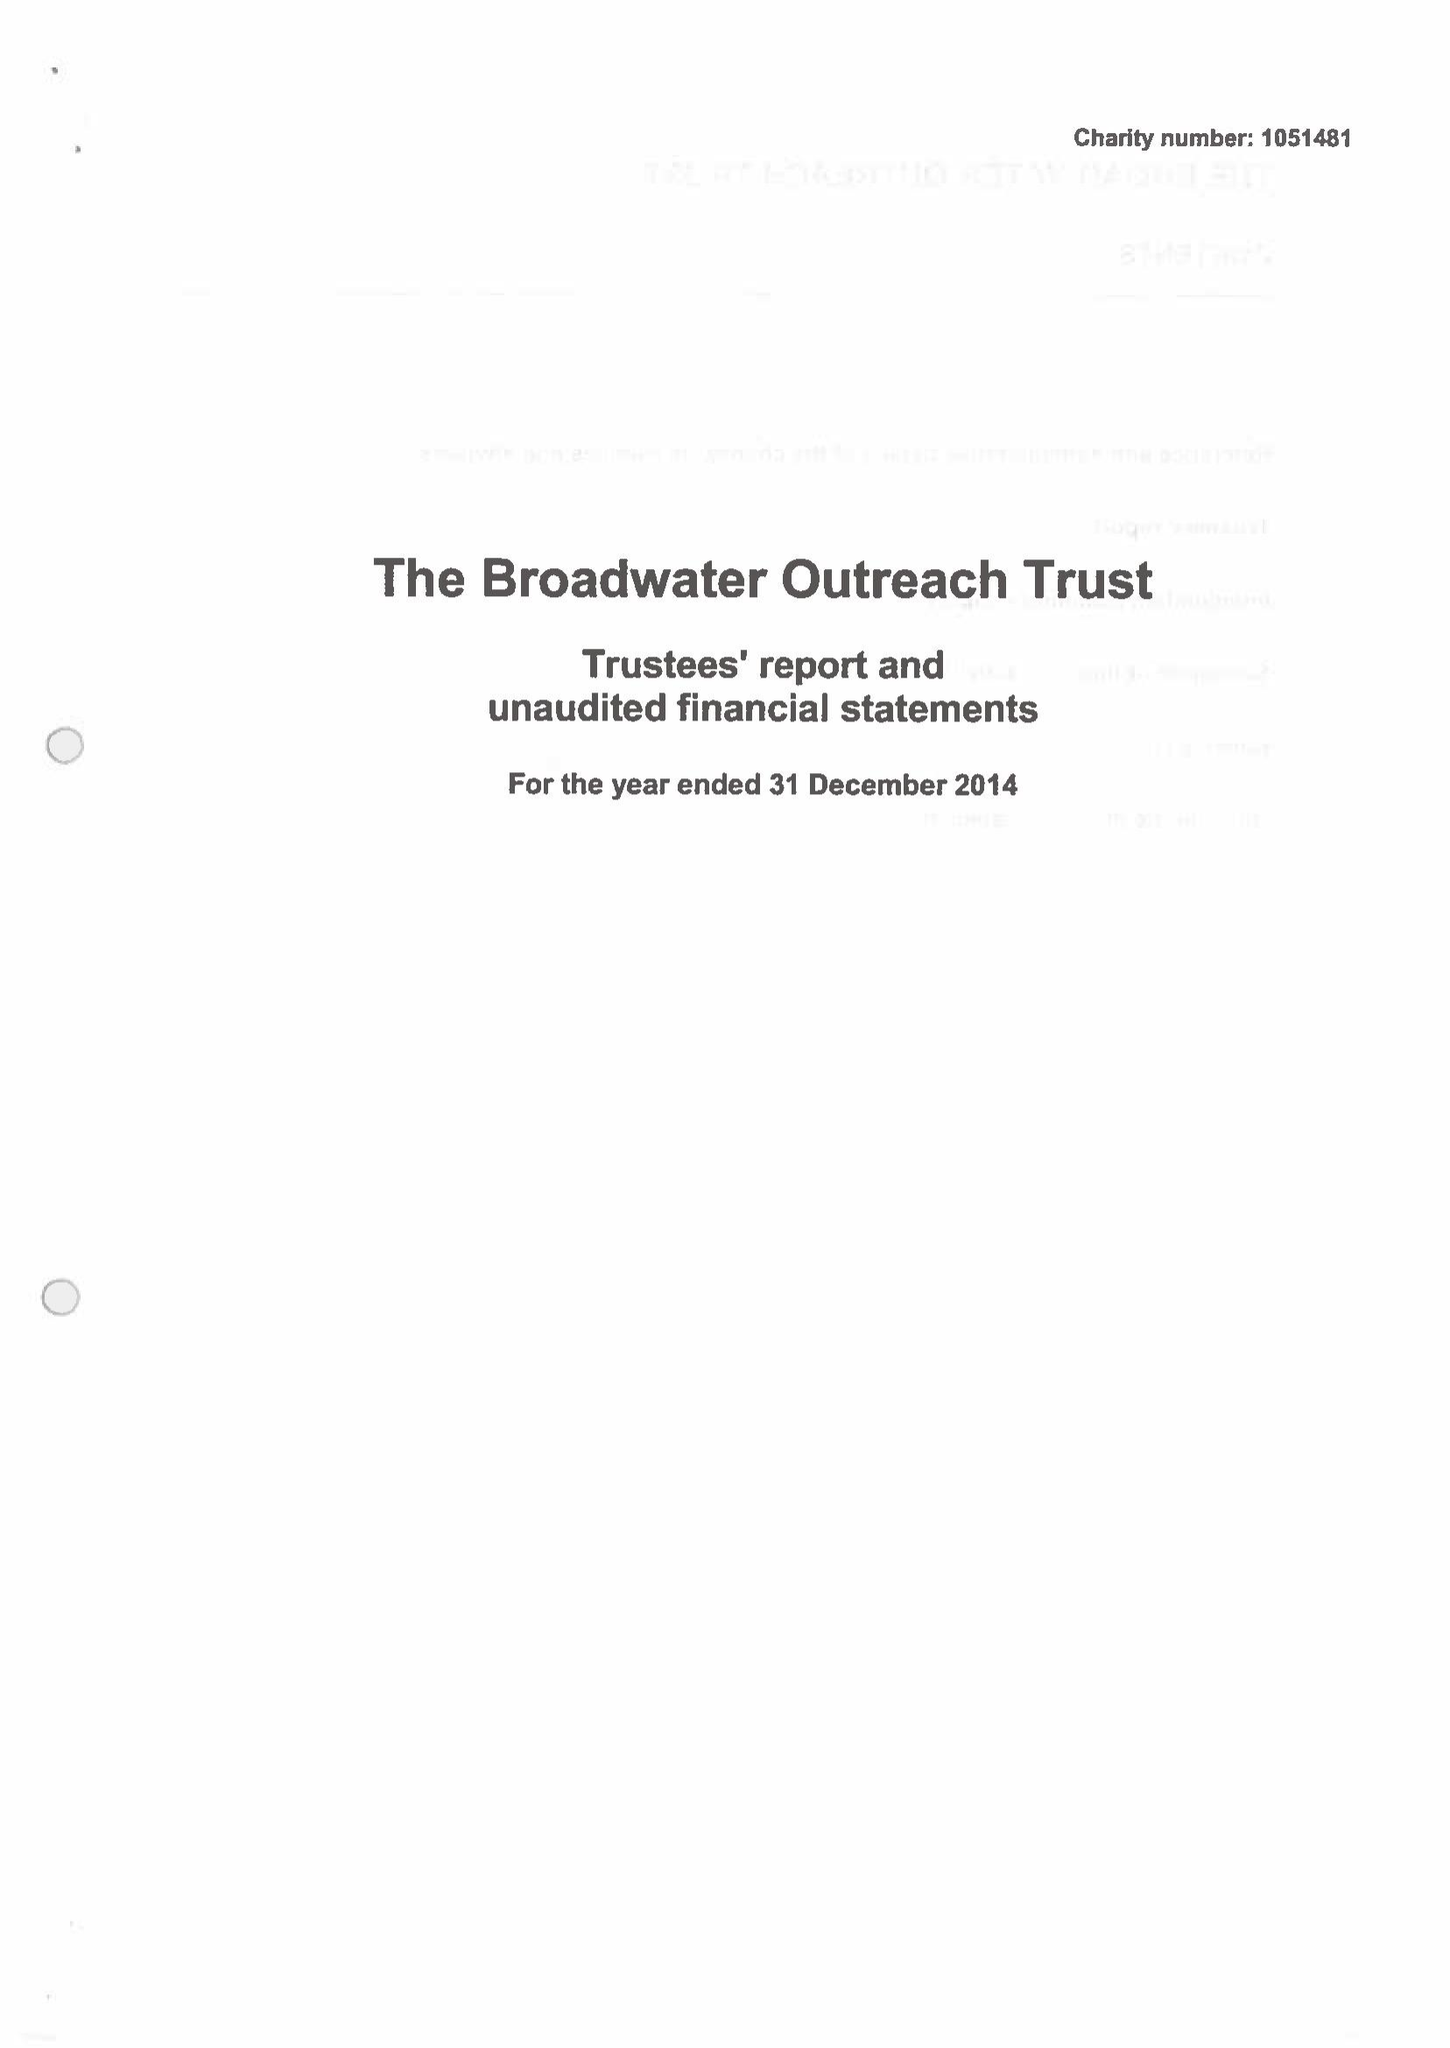What is the value for the address__post_town?
Answer the question using a single word or phrase. WORTHING 